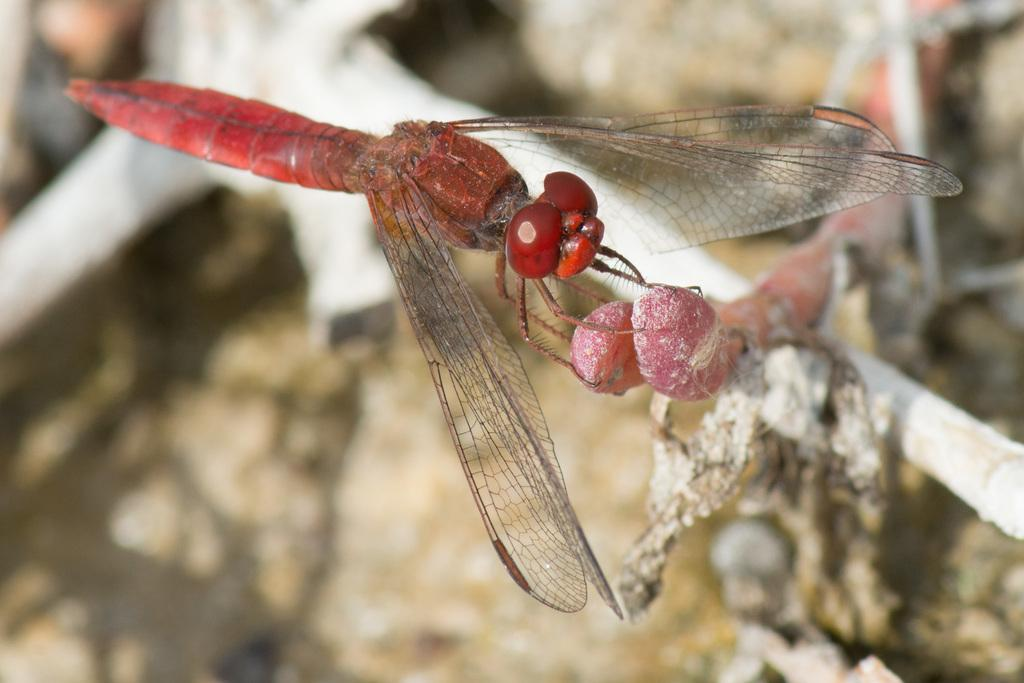What is the color of the fly in the image? The fly in the image is red. What is the fly doing in the image? The fly is eating a small fruit. What can be seen in the background of the image? There is a tree stem in the background of the image. Where is the chessboard located in the image? There is no chessboard present in the image. 